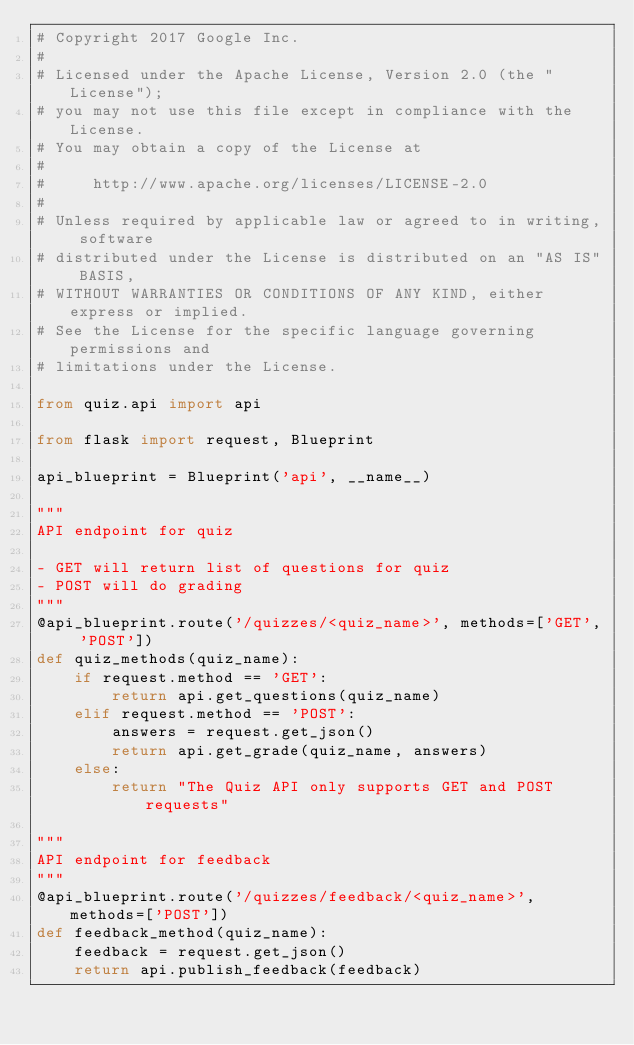<code> <loc_0><loc_0><loc_500><loc_500><_Python_># Copyright 2017 Google Inc.
#
# Licensed under the Apache License, Version 2.0 (the "License");
# you may not use this file except in compliance with the License.
# You may obtain a copy of the License at
#
#     http://www.apache.org/licenses/LICENSE-2.0
#
# Unless required by applicable law or agreed to in writing, software
# distributed under the License is distributed on an "AS IS" BASIS,
# WITHOUT WARRANTIES OR CONDITIONS OF ANY KIND, either express or implied.
# See the License for the specific language governing permissions and
# limitations under the License.

from quiz.api import api

from flask import request, Blueprint

api_blueprint = Blueprint('api', __name__)

"""
API endpoint for quiz

- GET will return list of questions for quiz
- POST will do grading
"""
@api_blueprint.route('/quizzes/<quiz_name>', methods=['GET', 'POST'])
def quiz_methods(quiz_name):
    if request.method == 'GET':
        return api.get_questions(quiz_name)
    elif request.method == 'POST':
        answers = request.get_json()
        return api.get_grade(quiz_name, answers)
    else:
        return "The Quiz API only supports GET and POST requests"

"""
API endpoint for feedback
"""
@api_blueprint.route('/quizzes/feedback/<quiz_name>', methods=['POST'])
def feedback_method(quiz_name):
    feedback = request.get_json()
    return api.publish_feedback(feedback)</code> 